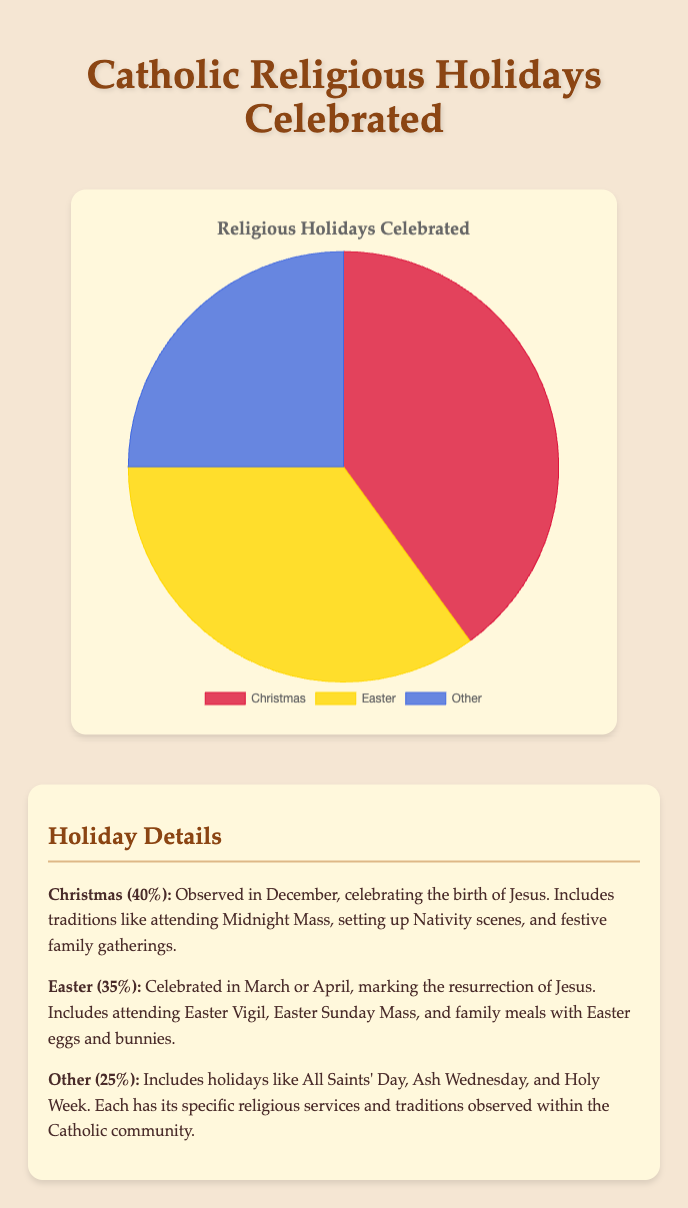What is the percentage of people who celebrate Christmas? The chart shows three components, with the percentage for Christmas clearly indicated as 40%.
Answer: 40% What is the difference between the percentage of people celebrating Christmas and Easter? The percentage for Christmas is 40% and for Easter is 35%. Subtract the percentage for Easter from Christmas: 40% - 35% = 5%.
Answer: 5% How does the percentage of people celebrating 'Other' holidays compare to those celebrating Easter? The chart indicates 35% for Easter and 25% for Other holidays. Since 35% is greater than 25%, more people celebrate Easter compared to Other holidays.
Answer: Easter > Other Combine the percentages of people celebrating Christmas and Easter. What is the total? The combined percentage is the sum of the percentages for Christmas (40%) and Easter (35%): 40% + 35% = 75%.
Answer: 75% Which holiday has the least number of celebrations? The chart lists three holidays, with 'Other' holidays having the smallest percentage at 25%.
Answer: Other If you were to rank the holidays by the percentage of observance, which holiday ranks second? Based on the chart, Christmas is first at 40%, Easter is second at 35%, and Other holidays are third at 25%. Thus, Easter ranks second.
Answer: Easter What are the represented colors for Christmas, Easter, and Other holidays? The legend in the chart indicates that Christmas is represented by red, Easter by gold, and Other by blue.
Answer: Christmas: red, Easter: gold, Other: blue Calculate the average percentage of people celebrating Christmas, Easter, and Other holidays. Sum the percentages (Christmas: 40%, Easter: 35%, Other: 25%) and divide by the number of holidays: (40% + 35% + 25%) / 3 = 100% / 3 ≈ 33.33%.
Answer: 33.33% By how much does the percentage of people celebrating Christmas exceed the combined percentage of those celebrating 'Other' holidays? Christmas has 40% while Other holidays have 25%. The difference is 40% - 25% = 15%.
Answer: 15% 